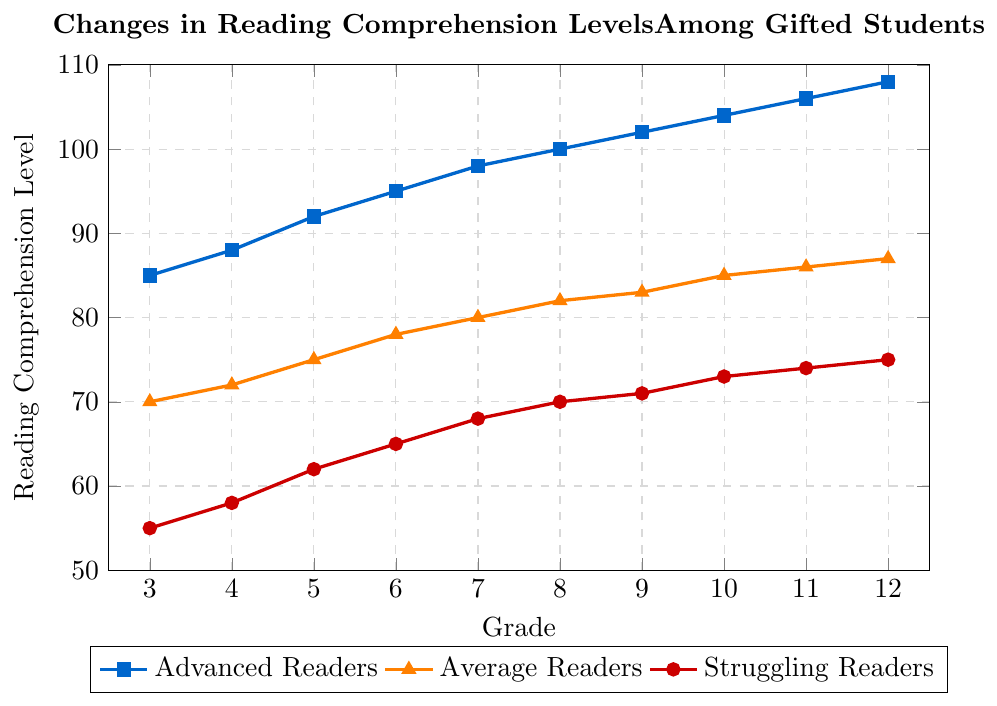Which grade shows the highest reading comprehension level for Advanced Readers? The line representing Advanced Readers shows highest reading comprehension in Grade 12 at the point (12, 108).
Answer: 12 How does the reading comprehension level of Struggling Readers change from Grade 3 to Grade 6? In Grade 3, Struggling Readers have a reading comprehension level of 55, and in Grade 6, it increases to 65. The change is calculated as 65 - 55 = 10.
Answer: 10 Compare the reading comprehension levels of Average Readers and Advanced Readers in Grade 5. For Grade 5, the chart shows that Average Readers are at 75, while Advanced Readers are at 92. Advanced Readers have a higher reading comprehension level.
Answer: Advanced Readers What is the average reading comprehension level for Advanced Readers over all grades? Sum the reading comprehension levels for Advanced Readers across all grades (85 + 88 + 92 + 95 + 98 + 100 + 102 + 104 + 106 + 108) = 978, then divide by the number of grades (10). The average is 978 / 10 = 97.8.
Answer: 97.8 Which group shows the most significant improvement in reading comprehension from Grade 8 to Grade 12? Calculate the changes for each group: Advanced Readers (108 - 100 = 8), Average Readers (87 - 82 = 5), Struggling Readers (75 - 70 = 5). Advanced Readers show the most significant improvement.
Answer: Advanced Readers Which grade shows the smallest gap in reading comprehension levels between Average Readers and Struggling Readers? Look at the differences: Grade 3 (70 - 55 = 15), Grade 4 (72 - 58 = 14), Grade 5 (75 - 62 = 13), Grade 6 (78 - 65 = 13), Grade 7 (80 - 68 = 12), Grade 8 (82 - 70 = 12), Grade 9 (83 - 71 = 12), Grade 10 (85 - 73 = 12), Grade 11 (86 - 74 = 12), Grade 12 (87 - 75 = 12). The smallest gap is in Grade 7, 8, 9, 10, 11, and 12, all with a difference of 12.
Answer: Grade 7, 8, 9, 10, 11, 12 What is the reading comprehension level of the group marked with blue color in Grade 10? The blue-colored line represents Advanced Readers, and their reading comprehension level at Grade 10 is 104.
Answer: 104 How many grades show a reading comprehension level above 90 for Advanced Readers? Check the grades in the graph: Grades 5, 6, 7, 8, 9, 10, 11, 12 all have levels above 90.
Answer: 8 What is the difference in the reading comprehension levels between the highest and lowest performing groups in Grade 9? In Grade 9, Advanced Readers are at 102, Average Readers at 83, and Struggling Readers at 71. The difference between Advanced Readers and Struggling Readers is 102 - 71 = 31.
Answer: 31 